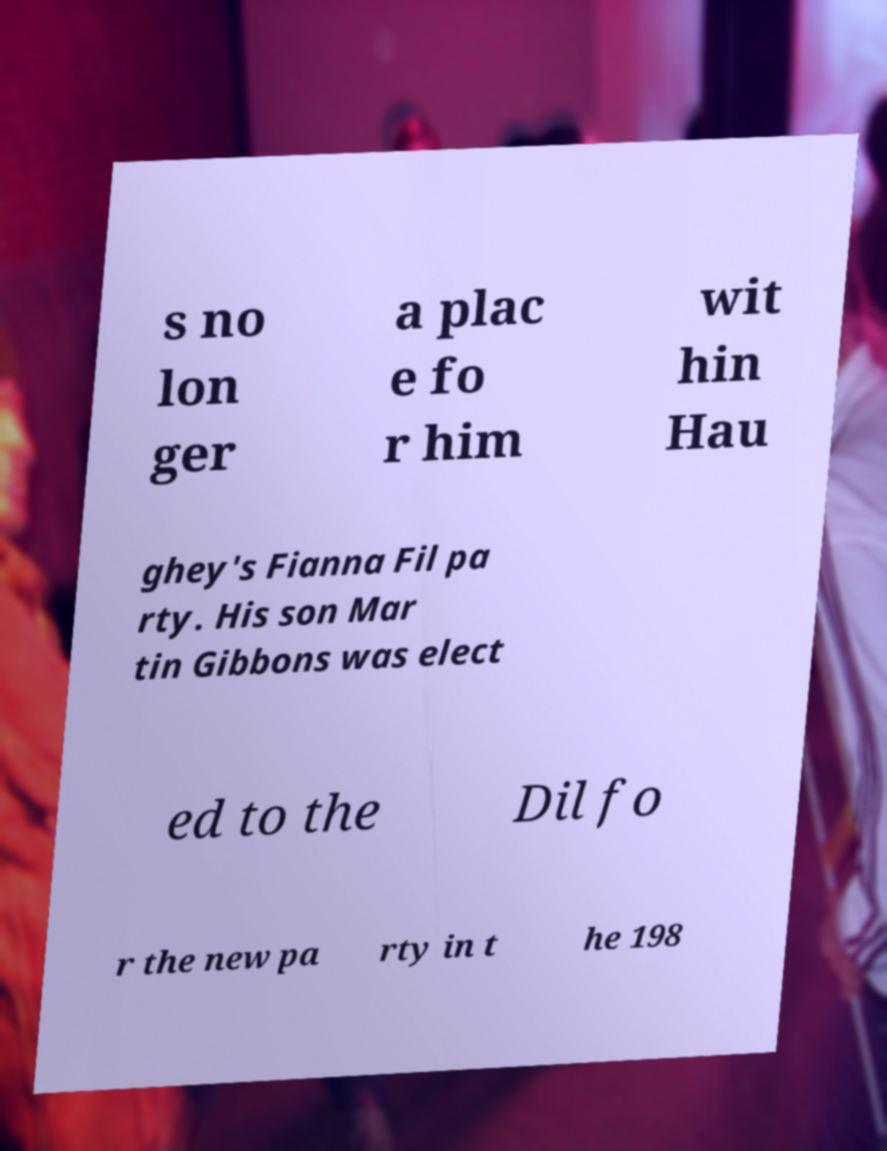What messages or text are displayed in this image? I need them in a readable, typed format. s no lon ger a plac e fo r him wit hin Hau ghey's Fianna Fil pa rty. His son Mar tin Gibbons was elect ed to the Dil fo r the new pa rty in t he 198 